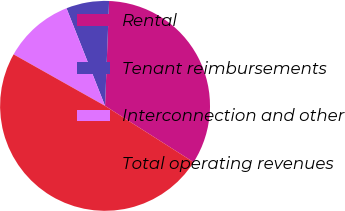Convert chart. <chart><loc_0><loc_0><loc_500><loc_500><pie_chart><fcel>Rental<fcel>Tenant reimbursements<fcel>Interconnection and other<fcel>Total operating revenues<nl><fcel>33.4%<fcel>6.6%<fcel>10.85%<fcel>49.14%<nl></chart> 